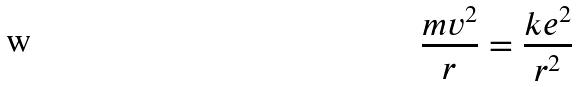Convert formula to latex. <formula><loc_0><loc_0><loc_500><loc_500>\frac { m v ^ { 2 } } { r } = \frac { k e ^ { 2 } } { r ^ { 2 } }</formula> 